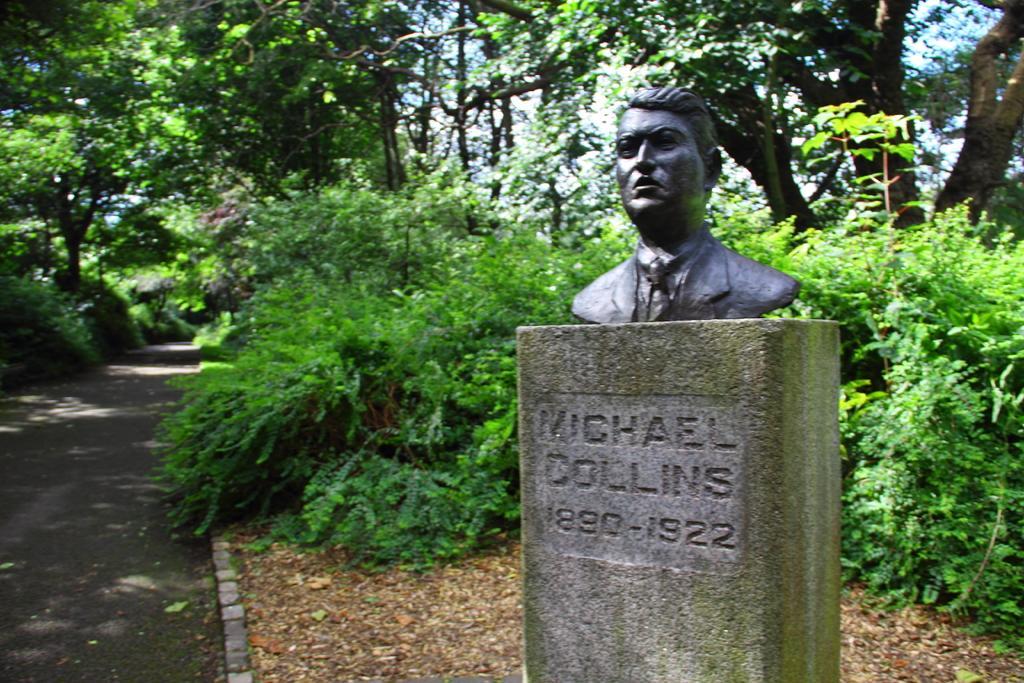Could you give a brief overview of what you see in this image? In this image, we can see a sculpture on the pillar. Here we can see some text and numerical numbers on the pillar. Background we can see so many trees, plants and road. 